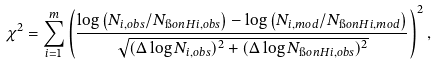Convert formula to latex. <formula><loc_0><loc_0><loc_500><loc_500>\chi ^ { 2 } = \sum _ { i = 1 } ^ { m } \left ( \frac { \log \left ( N _ { i , o b s } / N _ { \i o n { H } { i } , o b s } \right ) - \log \left ( N _ { i , m o d } / N _ { \i o n { H } { i } , m o d } \right ) } { \sqrt { ( \Delta \log N _ { i , o b s } ) ^ { 2 } + ( \Delta \log N _ { \i o n { H } { i } , o b s } ) ^ { 2 } } } \right ) ^ { 2 } ,</formula> 